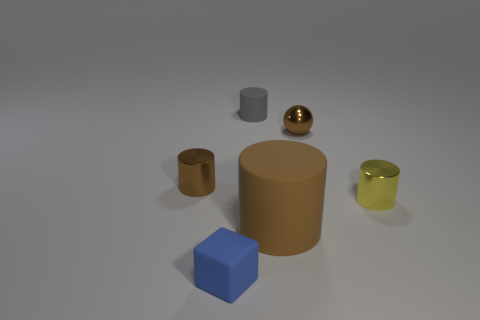Is the big matte object the same color as the ball?
Make the answer very short. Yes. There is a big thing that is the same color as the small ball; what is its material?
Your answer should be very brief. Rubber. Are there any gray shiny objects that have the same shape as the large matte thing?
Ensure brevity in your answer.  No. Is the tiny object that is on the left side of the blue cube made of the same material as the tiny brown object to the right of the small brown metallic cylinder?
Your response must be concise. Yes. What is the size of the cylinder in front of the metallic cylinder in front of the metallic cylinder behind the small yellow cylinder?
Provide a succinct answer. Large. There is a blue block that is the same size as the gray object; what is it made of?
Offer a very short reply. Rubber. Is there a brown metal cylinder that has the same size as the shiny ball?
Provide a short and direct response. Yes. Is the tiny gray thing the same shape as the tiny yellow thing?
Give a very brief answer. Yes. There is a tiny shiny cylinder on the left side of the small matte cylinder behind the small blue block; are there any tiny yellow things that are in front of it?
Provide a short and direct response. Yes. What number of other objects are the same color as the large matte thing?
Provide a succinct answer. 2. 